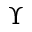<formula> <loc_0><loc_0><loc_500><loc_500>\Upsilon</formula> 